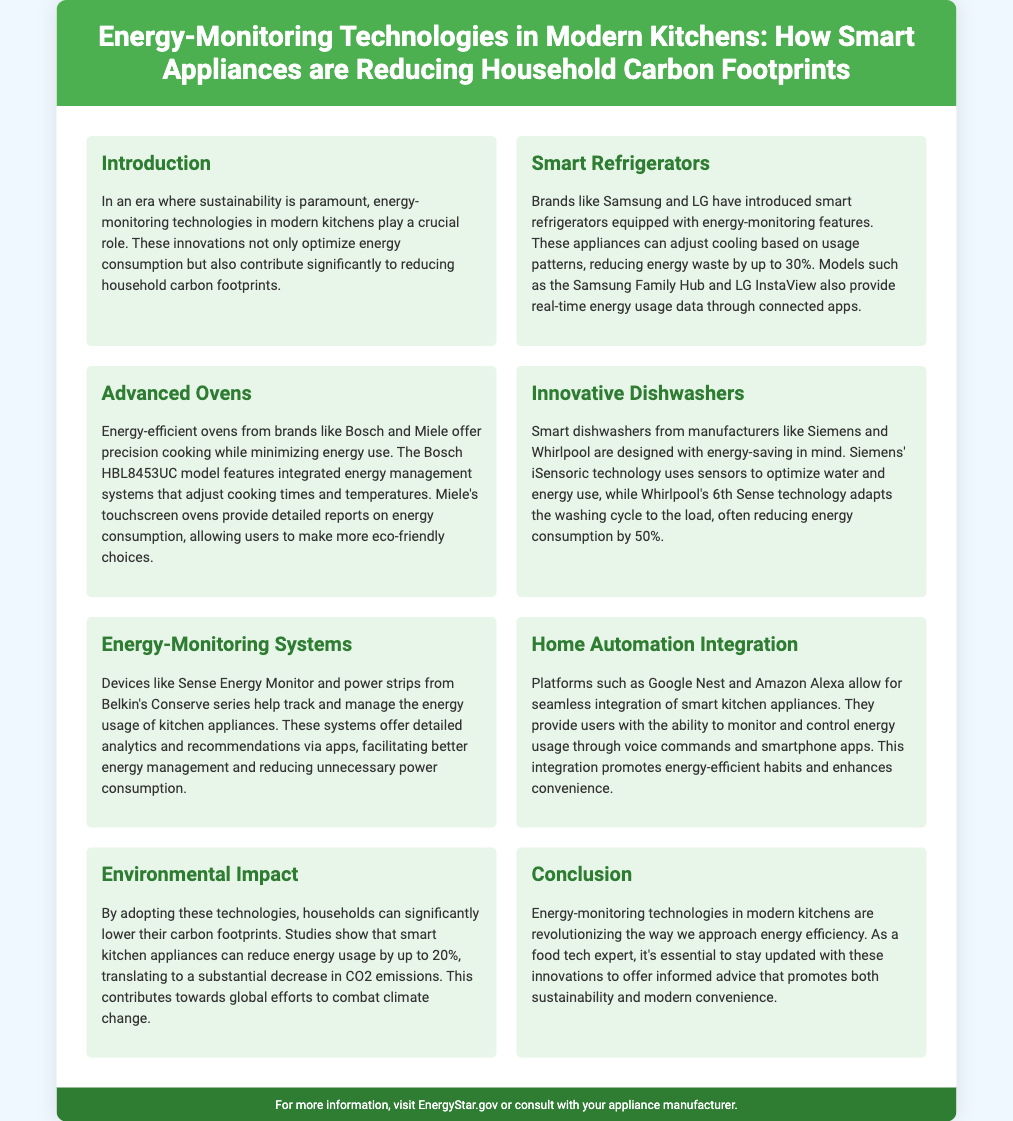What do smart refrigerators reduce energy waste by? The document specifies that smart refrigerators can reduce energy waste by up to 30%.
Answer: 30% Which brand features the HBL8453UC model? The model HBL8453UC is highlighted as an energy-efficient oven from Bosch.
Answer: Bosch What is the title of the poster? The title of the poster provides an overview of the content, stating it concerns energy-monitoring technologies and smart appliances.
Answer: Energy-Monitoring Technologies in Modern Kitchens: How Smart Appliances are Reducing Household Carbon Footprints How much can smart kitchen appliances reduce energy usage by? The document states that smart kitchen appliances can reduce energy usage by up to 20%.
Answer: 20% What technology does Siemens' smart dishwasher use? The document mentions that Siemens' smart dishwasher uses iSensoric technology for optimization.
Answer: iSensoric What is an advantage of home automation integration mentioned? The poster highlights convenience as a benefit of integrating smart kitchen appliances through home automation platforms.
Answer: Convenience What is the environmental impact of energy-monitoring technologies? The document states that these technologies contribute to lowering carbon footprints and CO2 emissions.
Answer: Lowering carbon footprints What type of device is the Sense Energy Monitor classified as? The Sense Energy Monitor is categorized as an energy-monitoring system in the document.
Answer: Energy-monitoring system 